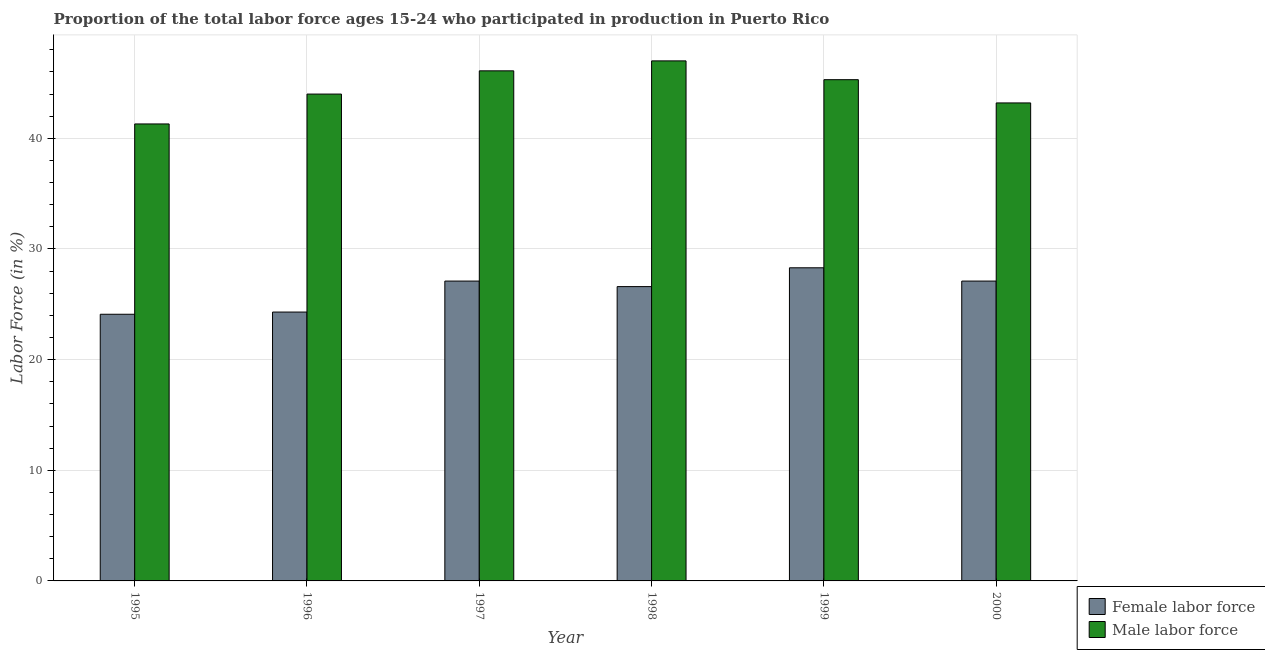How many groups of bars are there?
Offer a very short reply. 6. Are the number of bars on each tick of the X-axis equal?
Offer a terse response. Yes. How many bars are there on the 5th tick from the right?
Ensure brevity in your answer.  2. What is the percentage of female labor force in 1995?
Give a very brief answer. 24.1. Across all years, what is the minimum percentage of male labour force?
Your answer should be compact. 41.3. In which year was the percentage of female labor force maximum?
Provide a short and direct response. 1999. In which year was the percentage of male labour force minimum?
Your answer should be compact. 1995. What is the total percentage of male labour force in the graph?
Make the answer very short. 266.9. What is the difference between the percentage of female labor force in 1996 and that in 2000?
Make the answer very short. -2.8. What is the average percentage of male labour force per year?
Provide a short and direct response. 44.48. What is the ratio of the percentage of female labor force in 1995 to that in 1996?
Provide a short and direct response. 0.99. Is the percentage of female labor force in 1996 less than that in 1999?
Provide a short and direct response. Yes. Is the difference between the percentage of male labour force in 1996 and 2000 greater than the difference between the percentage of female labor force in 1996 and 2000?
Offer a very short reply. No. What is the difference between the highest and the second highest percentage of male labour force?
Make the answer very short. 0.9. What is the difference between the highest and the lowest percentage of female labor force?
Provide a short and direct response. 4.2. Is the sum of the percentage of male labour force in 1999 and 2000 greater than the maximum percentage of female labor force across all years?
Your answer should be very brief. Yes. What does the 2nd bar from the left in 1995 represents?
Your answer should be compact. Male labor force. What does the 2nd bar from the right in 1995 represents?
Your answer should be very brief. Female labor force. How many bars are there?
Ensure brevity in your answer.  12. Are the values on the major ticks of Y-axis written in scientific E-notation?
Make the answer very short. No. How many legend labels are there?
Offer a very short reply. 2. What is the title of the graph?
Offer a terse response. Proportion of the total labor force ages 15-24 who participated in production in Puerto Rico. Does "Transport services" appear as one of the legend labels in the graph?
Your answer should be very brief. No. What is the label or title of the X-axis?
Offer a terse response. Year. What is the Labor Force (in %) in Female labor force in 1995?
Offer a terse response. 24.1. What is the Labor Force (in %) of Male labor force in 1995?
Provide a short and direct response. 41.3. What is the Labor Force (in %) in Female labor force in 1996?
Make the answer very short. 24.3. What is the Labor Force (in %) in Male labor force in 1996?
Ensure brevity in your answer.  44. What is the Labor Force (in %) in Female labor force in 1997?
Ensure brevity in your answer.  27.1. What is the Labor Force (in %) of Male labor force in 1997?
Your response must be concise. 46.1. What is the Labor Force (in %) in Female labor force in 1998?
Offer a terse response. 26.6. What is the Labor Force (in %) in Male labor force in 1998?
Give a very brief answer. 47. What is the Labor Force (in %) in Female labor force in 1999?
Your answer should be compact. 28.3. What is the Labor Force (in %) in Male labor force in 1999?
Make the answer very short. 45.3. What is the Labor Force (in %) in Female labor force in 2000?
Keep it short and to the point. 27.1. What is the Labor Force (in %) in Male labor force in 2000?
Your answer should be very brief. 43.2. Across all years, what is the maximum Labor Force (in %) in Female labor force?
Your answer should be very brief. 28.3. Across all years, what is the minimum Labor Force (in %) of Female labor force?
Offer a very short reply. 24.1. Across all years, what is the minimum Labor Force (in %) in Male labor force?
Keep it short and to the point. 41.3. What is the total Labor Force (in %) in Female labor force in the graph?
Provide a short and direct response. 157.5. What is the total Labor Force (in %) in Male labor force in the graph?
Offer a very short reply. 266.9. What is the difference between the Labor Force (in %) in Female labor force in 1995 and that in 1996?
Ensure brevity in your answer.  -0.2. What is the difference between the Labor Force (in %) of Female labor force in 1995 and that in 1997?
Keep it short and to the point. -3. What is the difference between the Labor Force (in %) of Male labor force in 1995 and that in 1997?
Provide a short and direct response. -4.8. What is the difference between the Labor Force (in %) of Female labor force in 1995 and that in 1998?
Offer a terse response. -2.5. What is the difference between the Labor Force (in %) in Male labor force in 1995 and that in 1998?
Ensure brevity in your answer.  -5.7. What is the difference between the Labor Force (in %) of Female labor force in 1995 and that in 2000?
Your answer should be compact. -3. What is the difference between the Labor Force (in %) in Male labor force in 1995 and that in 2000?
Give a very brief answer. -1.9. What is the difference between the Labor Force (in %) in Female labor force in 1996 and that in 1997?
Your answer should be compact. -2.8. What is the difference between the Labor Force (in %) in Male labor force in 1996 and that in 1997?
Offer a terse response. -2.1. What is the difference between the Labor Force (in %) of Female labor force in 1996 and that in 1998?
Keep it short and to the point. -2.3. What is the difference between the Labor Force (in %) in Male labor force in 1996 and that in 1998?
Ensure brevity in your answer.  -3. What is the difference between the Labor Force (in %) in Female labor force in 1996 and that in 1999?
Offer a very short reply. -4. What is the difference between the Labor Force (in %) of Male labor force in 1997 and that in 1998?
Offer a terse response. -0.9. What is the difference between the Labor Force (in %) of Female labor force in 1997 and that in 1999?
Make the answer very short. -1.2. What is the difference between the Labor Force (in %) in Male labor force in 1997 and that in 1999?
Provide a succinct answer. 0.8. What is the difference between the Labor Force (in %) in Female labor force in 1997 and that in 2000?
Your answer should be very brief. 0. What is the difference between the Labor Force (in %) of Female labor force in 1998 and that in 1999?
Provide a short and direct response. -1.7. What is the difference between the Labor Force (in %) in Female labor force in 1999 and that in 2000?
Offer a very short reply. 1.2. What is the difference between the Labor Force (in %) of Male labor force in 1999 and that in 2000?
Ensure brevity in your answer.  2.1. What is the difference between the Labor Force (in %) in Female labor force in 1995 and the Labor Force (in %) in Male labor force in 1996?
Make the answer very short. -19.9. What is the difference between the Labor Force (in %) in Female labor force in 1995 and the Labor Force (in %) in Male labor force in 1997?
Your answer should be very brief. -22. What is the difference between the Labor Force (in %) in Female labor force in 1995 and the Labor Force (in %) in Male labor force in 1998?
Your response must be concise. -22.9. What is the difference between the Labor Force (in %) in Female labor force in 1995 and the Labor Force (in %) in Male labor force in 1999?
Your response must be concise. -21.2. What is the difference between the Labor Force (in %) in Female labor force in 1995 and the Labor Force (in %) in Male labor force in 2000?
Offer a very short reply. -19.1. What is the difference between the Labor Force (in %) in Female labor force in 1996 and the Labor Force (in %) in Male labor force in 1997?
Give a very brief answer. -21.8. What is the difference between the Labor Force (in %) of Female labor force in 1996 and the Labor Force (in %) of Male labor force in 1998?
Provide a short and direct response. -22.7. What is the difference between the Labor Force (in %) in Female labor force in 1996 and the Labor Force (in %) in Male labor force in 1999?
Offer a terse response. -21. What is the difference between the Labor Force (in %) of Female labor force in 1996 and the Labor Force (in %) of Male labor force in 2000?
Offer a terse response. -18.9. What is the difference between the Labor Force (in %) in Female labor force in 1997 and the Labor Force (in %) in Male labor force in 1998?
Your response must be concise. -19.9. What is the difference between the Labor Force (in %) in Female labor force in 1997 and the Labor Force (in %) in Male labor force in 1999?
Keep it short and to the point. -18.2. What is the difference between the Labor Force (in %) of Female labor force in 1997 and the Labor Force (in %) of Male labor force in 2000?
Provide a succinct answer. -16.1. What is the difference between the Labor Force (in %) of Female labor force in 1998 and the Labor Force (in %) of Male labor force in 1999?
Your response must be concise. -18.7. What is the difference between the Labor Force (in %) in Female labor force in 1998 and the Labor Force (in %) in Male labor force in 2000?
Your response must be concise. -16.6. What is the difference between the Labor Force (in %) of Female labor force in 1999 and the Labor Force (in %) of Male labor force in 2000?
Offer a terse response. -14.9. What is the average Labor Force (in %) of Female labor force per year?
Give a very brief answer. 26.25. What is the average Labor Force (in %) of Male labor force per year?
Provide a succinct answer. 44.48. In the year 1995, what is the difference between the Labor Force (in %) in Female labor force and Labor Force (in %) in Male labor force?
Your answer should be compact. -17.2. In the year 1996, what is the difference between the Labor Force (in %) in Female labor force and Labor Force (in %) in Male labor force?
Ensure brevity in your answer.  -19.7. In the year 1998, what is the difference between the Labor Force (in %) of Female labor force and Labor Force (in %) of Male labor force?
Ensure brevity in your answer.  -20.4. In the year 1999, what is the difference between the Labor Force (in %) of Female labor force and Labor Force (in %) of Male labor force?
Provide a succinct answer. -17. In the year 2000, what is the difference between the Labor Force (in %) in Female labor force and Labor Force (in %) in Male labor force?
Provide a short and direct response. -16.1. What is the ratio of the Labor Force (in %) in Male labor force in 1995 to that in 1996?
Give a very brief answer. 0.94. What is the ratio of the Labor Force (in %) in Female labor force in 1995 to that in 1997?
Provide a short and direct response. 0.89. What is the ratio of the Labor Force (in %) in Male labor force in 1995 to that in 1997?
Your answer should be very brief. 0.9. What is the ratio of the Labor Force (in %) in Female labor force in 1995 to that in 1998?
Give a very brief answer. 0.91. What is the ratio of the Labor Force (in %) in Male labor force in 1995 to that in 1998?
Give a very brief answer. 0.88. What is the ratio of the Labor Force (in %) of Female labor force in 1995 to that in 1999?
Provide a succinct answer. 0.85. What is the ratio of the Labor Force (in %) in Male labor force in 1995 to that in 1999?
Offer a very short reply. 0.91. What is the ratio of the Labor Force (in %) in Female labor force in 1995 to that in 2000?
Give a very brief answer. 0.89. What is the ratio of the Labor Force (in %) in Male labor force in 1995 to that in 2000?
Provide a short and direct response. 0.96. What is the ratio of the Labor Force (in %) in Female labor force in 1996 to that in 1997?
Your answer should be compact. 0.9. What is the ratio of the Labor Force (in %) of Male labor force in 1996 to that in 1997?
Provide a succinct answer. 0.95. What is the ratio of the Labor Force (in %) in Female labor force in 1996 to that in 1998?
Your answer should be compact. 0.91. What is the ratio of the Labor Force (in %) of Male labor force in 1996 to that in 1998?
Offer a very short reply. 0.94. What is the ratio of the Labor Force (in %) of Female labor force in 1996 to that in 1999?
Your response must be concise. 0.86. What is the ratio of the Labor Force (in %) in Male labor force in 1996 to that in 1999?
Offer a terse response. 0.97. What is the ratio of the Labor Force (in %) in Female labor force in 1996 to that in 2000?
Provide a short and direct response. 0.9. What is the ratio of the Labor Force (in %) of Male labor force in 1996 to that in 2000?
Offer a very short reply. 1.02. What is the ratio of the Labor Force (in %) of Female labor force in 1997 to that in 1998?
Keep it short and to the point. 1.02. What is the ratio of the Labor Force (in %) in Male labor force in 1997 to that in 1998?
Offer a terse response. 0.98. What is the ratio of the Labor Force (in %) in Female labor force in 1997 to that in 1999?
Provide a short and direct response. 0.96. What is the ratio of the Labor Force (in %) in Male labor force in 1997 to that in 1999?
Provide a short and direct response. 1.02. What is the ratio of the Labor Force (in %) of Male labor force in 1997 to that in 2000?
Make the answer very short. 1.07. What is the ratio of the Labor Force (in %) in Female labor force in 1998 to that in 1999?
Your answer should be compact. 0.94. What is the ratio of the Labor Force (in %) in Male labor force in 1998 to that in 1999?
Give a very brief answer. 1.04. What is the ratio of the Labor Force (in %) in Female labor force in 1998 to that in 2000?
Ensure brevity in your answer.  0.98. What is the ratio of the Labor Force (in %) in Male labor force in 1998 to that in 2000?
Your answer should be very brief. 1.09. What is the ratio of the Labor Force (in %) in Female labor force in 1999 to that in 2000?
Ensure brevity in your answer.  1.04. What is the ratio of the Labor Force (in %) in Male labor force in 1999 to that in 2000?
Your response must be concise. 1.05. What is the difference between the highest and the second highest Labor Force (in %) in Female labor force?
Make the answer very short. 1.2. What is the difference between the highest and the lowest Labor Force (in %) in Female labor force?
Keep it short and to the point. 4.2. 